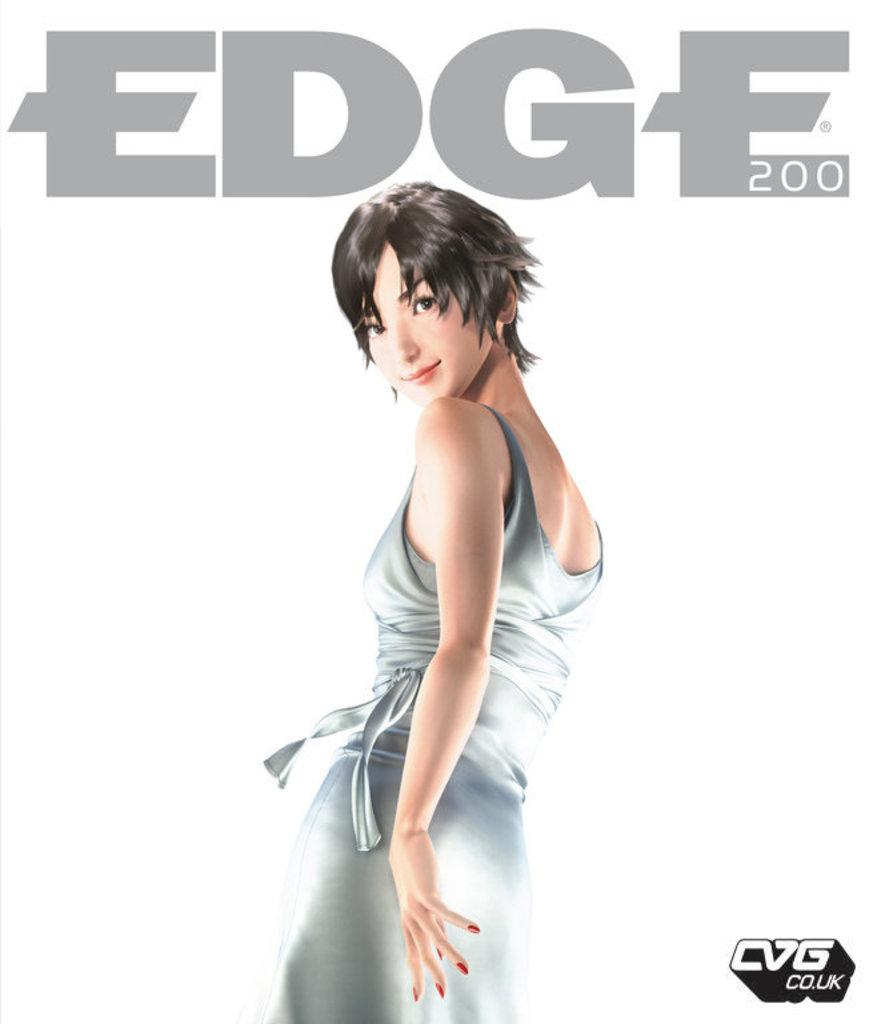What type of image is being described? The image is an animation and graphic. Can you describe the woman in the image? There is a woman standing in the image, and she is smiling. Is there any text present in the image? Yes, there is text written on the image. What type of snake can be seen slithering across the book in the image? There is no snake or book present in the image; it features an animation and graphic of a woman. 